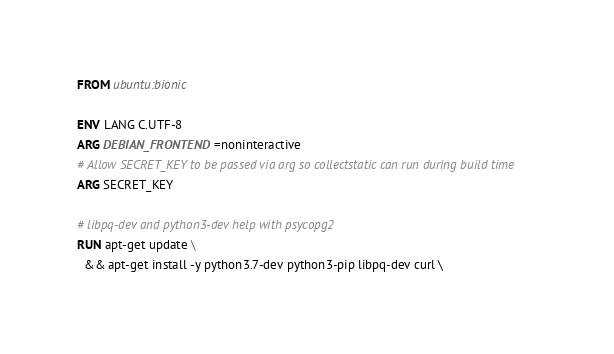Convert code to text. <code><loc_0><loc_0><loc_500><loc_500><_Dockerfile_>FROM ubuntu:bionic

ENV LANG C.UTF-8
ARG DEBIAN_FRONTEND=noninteractive
# Allow SECRET_KEY to be passed via arg so collectstatic can run during build time
ARG SECRET_KEY

# libpq-dev and python3-dev help with psycopg2
RUN apt-get update \
  && apt-get install -y python3.7-dev python3-pip libpq-dev curl \</code> 